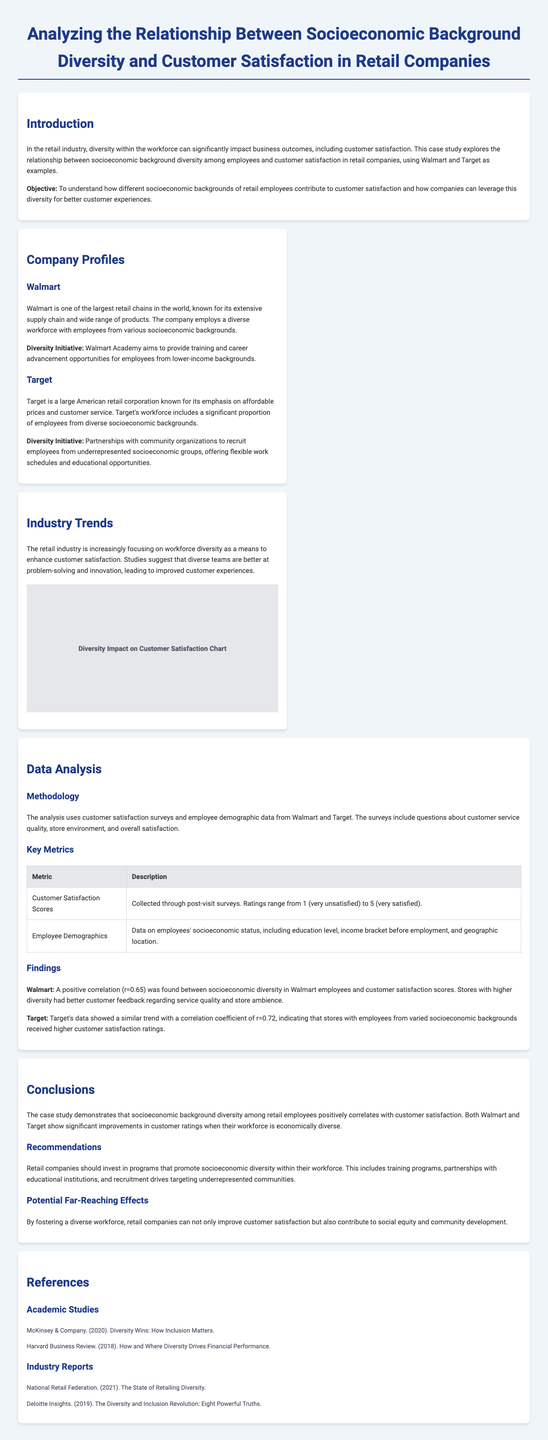What is the title of the case study? The title of the case study is presented prominently at the top of the document.
Answer: Analyzing the Relationship Between Socioeconomic Background Diversity and Customer Satisfaction in Retail Companies What correlation was found for Walmart's socioeconomic diversity? The document states the correlation coefficient found for Walmart's dataset.
Answer: r=0.65 Which company had a higher correlation coefficient, Walmart or Target? The document compares the correlation coefficients from both companies.
Answer: Target What diversity initiative does Walmart implement? The case study highlights a specific initiative by Walmart to support its diversity goals.
Answer: Walmart Academy What year was the McKinsey & Company report published? The reference section attributes the report to a specific year as mentioned.
Answer: 2020 What is the main objective of the case study? The introduction outlines the primary aim of the analysis clearly.
Answer: To understand how different socioeconomic backgrounds of retail employees contribute to customer satisfaction What type of data was collected for analysis? The section on data analysis mentions specific types of data collected for the study.
Answer: Customer satisfaction surveys and employee demographic data What is a suggested recommendation for retail companies? The recommendations section provides actionable suggestions based on findings.
Answer: Invest in programs that promote socioeconomic diversity What is the importance of diverse teams according to the industry trends section? The document mentions how diverse teams impact customer experiences.
Answer: Better at problem-solving and innovation 